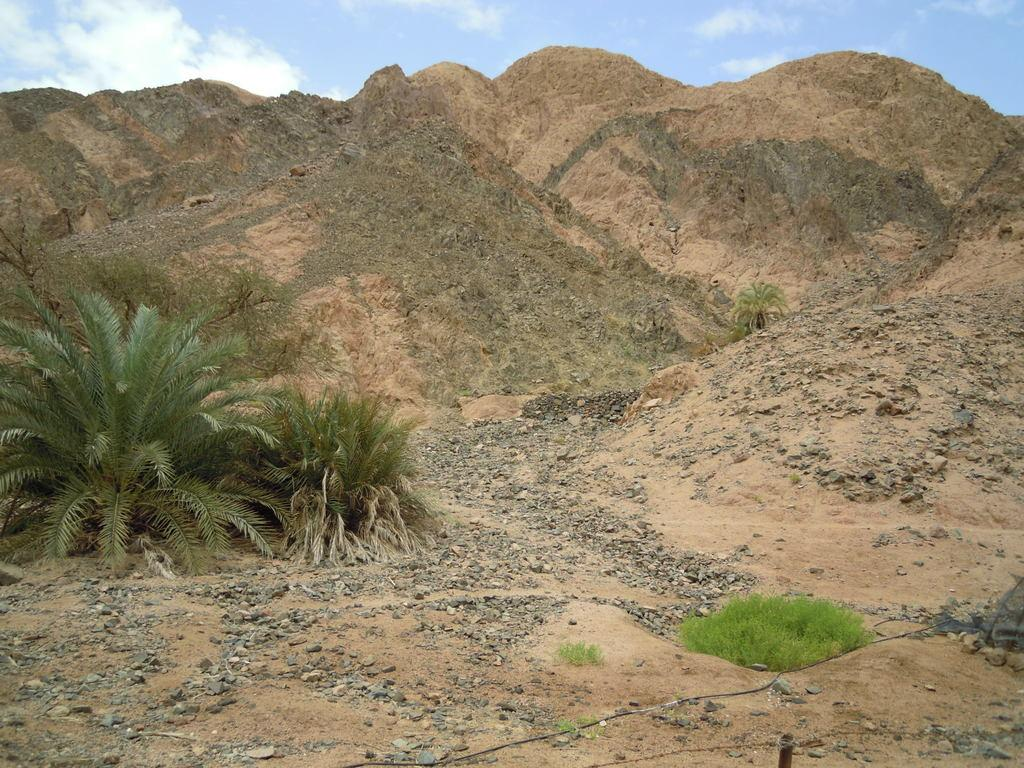What type of vegetation is present on the ground in the image? There are trees on the ground in the image. What other natural elements can be seen in the image? There is grass visible in the image. What additional objects are present in the image? There are stones in the image. What can be seen in the background of the image? There are hills in the background of the image, and the sky is visible. What is the condition of the sky in the image? Clouds are present in the sky. Can you tell me the size of the snail crawling on the office desk in the image? There is no snail or office desk present in the image; it features trees, grass, stones, hills, and a sky with clouds. 